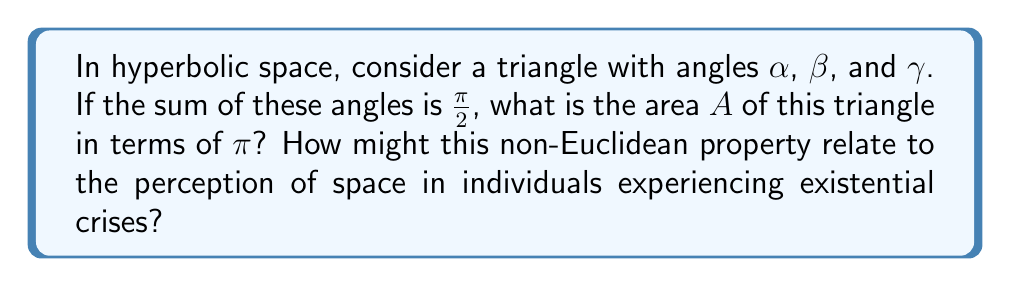Show me your answer to this math problem. 1) In hyperbolic geometry, the area of a triangle is given by the formula:

   $$A = \pi - (\alpha + \beta + \gamma)$$

   where $\alpha$, $\beta$, and $\gamma$ are the angles of the triangle.

2) We are given that $\alpha + \beta + \gamma = \frac{\pi}{2}$

3) Substituting this into the area formula:

   $$A = \pi - (\frac{\pi}{2})$$

4) Simplifying:

   $$A = \frac{\pi}{2}$$

5) Relating to existential therapy:
   The fact that the area of a triangle in hyperbolic space is determined by its angle deficit (how much less than $\pi$ the sum of its angles is) can be seen as a metaphor for how our perception of our life's "area" or significance is influenced by our perspective (angles). In existential crises, individuals often feel their life space is constrained or diminished, which could be likened to the strange properties of hyperbolic space where familiar Euclidean relationships no longer hold. Just as understanding hyperbolic geometry requires a shift in perspective, helping clients navigate existential crises often involves guiding them to view their life and choices from new angles, potentially expanding their perceived "area" of existence.
Answer: $\frac{\pi}{2}$ 